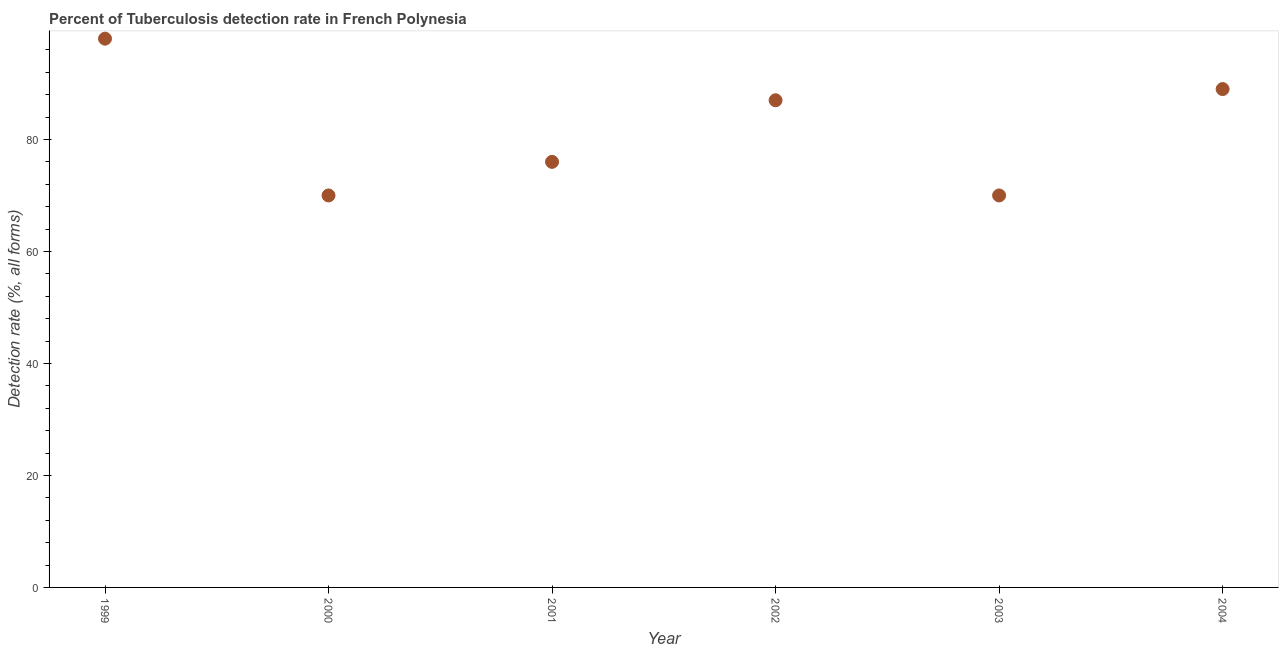What is the detection rate of tuberculosis in 1999?
Offer a very short reply. 98. Across all years, what is the maximum detection rate of tuberculosis?
Provide a short and direct response. 98. Across all years, what is the minimum detection rate of tuberculosis?
Make the answer very short. 70. In which year was the detection rate of tuberculosis maximum?
Make the answer very short. 1999. In which year was the detection rate of tuberculosis minimum?
Your response must be concise. 2000. What is the sum of the detection rate of tuberculosis?
Keep it short and to the point. 490. What is the difference between the detection rate of tuberculosis in 2002 and 2004?
Offer a terse response. -2. What is the average detection rate of tuberculosis per year?
Your response must be concise. 81.67. What is the median detection rate of tuberculosis?
Make the answer very short. 81.5. In how many years, is the detection rate of tuberculosis greater than 36 %?
Give a very brief answer. 6. Do a majority of the years between 2004 and 2002 (inclusive) have detection rate of tuberculosis greater than 72 %?
Make the answer very short. No. What is the ratio of the detection rate of tuberculosis in 1999 to that in 2004?
Offer a very short reply. 1.1. Is the difference between the detection rate of tuberculosis in 1999 and 2001 greater than the difference between any two years?
Provide a short and direct response. No. Is the sum of the detection rate of tuberculosis in 1999 and 2004 greater than the maximum detection rate of tuberculosis across all years?
Your answer should be compact. Yes. What is the difference between the highest and the lowest detection rate of tuberculosis?
Ensure brevity in your answer.  28. In how many years, is the detection rate of tuberculosis greater than the average detection rate of tuberculosis taken over all years?
Your answer should be very brief. 3. What is the difference between two consecutive major ticks on the Y-axis?
Offer a very short reply. 20. Are the values on the major ticks of Y-axis written in scientific E-notation?
Keep it short and to the point. No. Does the graph contain any zero values?
Offer a terse response. No. What is the title of the graph?
Your answer should be compact. Percent of Tuberculosis detection rate in French Polynesia. What is the label or title of the X-axis?
Ensure brevity in your answer.  Year. What is the label or title of the Y-axis?
Your answer should be compact. Detection rate (%, all forms). What is the Detection rate (%, all forms) in 2000?
Make the answer very short. 70. What is the Detection rate (%, all forms) in 2001?
Offer a terse response. 76. What is the Detection rate (%, all forms) in 2002?
Your response must be concise. 87. What is the Detection rate (%, all forms) in 2003?
Make the answer very short. 70. What is the Detection rate (%, all forms) in 2004?
Ensure brevity in your answer.  89. What is the difference between the Detection rate (%, all forms) in 1999 and 2003?
Give a very brief answer. 28. What is the difference between the Detection rate (%, all forms) in 2000 and 2001?
Your answer should be very brief. -6. What is the difference between the Detection rate (%, all forms) in 2001 and 2002?
Offer a very short reply. -11. What is the ratio of the Detection rate (%, all forms) in 1999 to that in 2001?
Ensure brevity in your answer.  1.29. What is the ratio of the Detection rate (%, all forms) in 1999 to that in 2002?
Your answer should be compact. 1.13. What is the ratio of the Detection rate (%, all forms) in 1999 to that in 2004?
Provide a succinct answer. 1.1. What is the ratio of the Detection rate (%, all forms) in 2000 to that in 2001?
Offer a very short reply. 0.92. What is the ratio of the Detection rate (%, all forms) in 2000 to that in 2002?
Offer a very short reply. 0.81. What is the ratio of the Detection rate (%, all forms) in 2000 to that in 2004?
Offer a very short reply. 0.79. What is the ratio of the Detection rate (%, all forms) in 2001 to that in 2002?
Give a very brief answer. 0.87. What is the ratio of the Detection rate (%, all forms) in 2001 to that in 2003?
Offer a very short reply. 1.09. What is the ratio of the Detection rate (%, all forms) in 2001 to that in 2004?
Offer a terse response. 0.85. What is the ratio of the Detection rate (%, all forms) in 2002 to that in 2003?
Your response must be concise. 1.24. What is the ratio of the Detection rate (%, all forms) in 2002 to that in 2004?
Offer a terse response. 0.98. What is the ratio of the Detection rate (%, all forms) in 2003 to that in 2004?
Your answer should be compact. 0.79. 